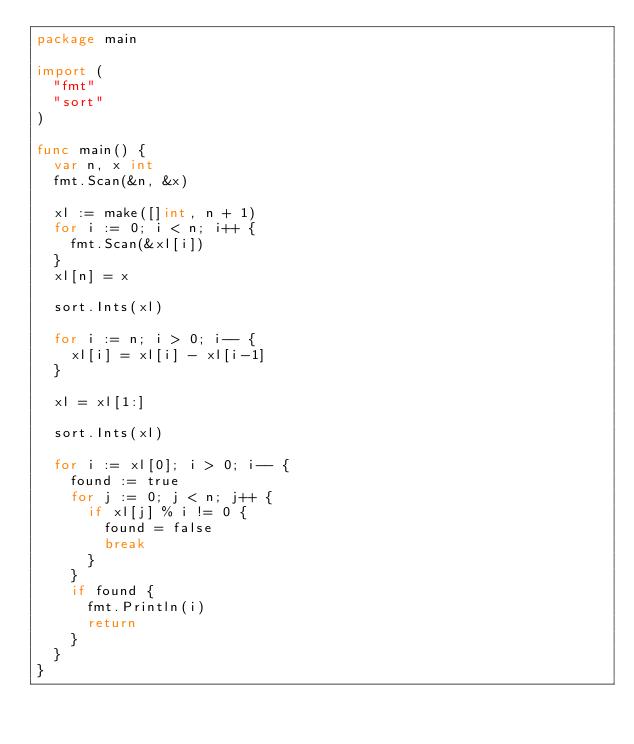<code> <loc_0><loc_0><loc_500><loc_500><_Go_>package main

import (
	"fmt"
	"sort"
)

func main() {
	var n, x int
	fmt.Scan(&n, &x)

	xl := make([]int, n + 1)
	for i := 0; i < n; i++ {
		fmt.Scan(&xl[i])
	}
	xl[n] = x

	sort.Ints(xl)

	for i := n; i > 0; i-- {
		xl[i] = xl[i] - xl[i-1]
	}

	xl = xl[1:]

	sort.Ints(xl)

	for i := xl[0]; i > 0; i-- {
		found := true
		for j := 0; j < n; j++ {
			if xl[j] % i != 0 {
				found = false
				break
			}
		}
		if found {
			fmt.Println(i)
			return
		}
	}
}</code> 